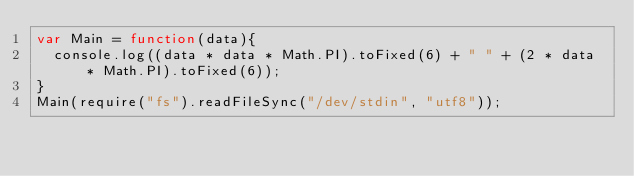Convert code to text. <code><loc_0><loc_0><loc_500><loc_500><_JavaScript_>var Main = function(data){
	console.log((data * data * Math.PI).toFixed(6) + " " + (2 * data * Math.PI).toFixed(6));
}
Main(require("fs").readFileSync("/dev/stdin", "utf8"));</code> 